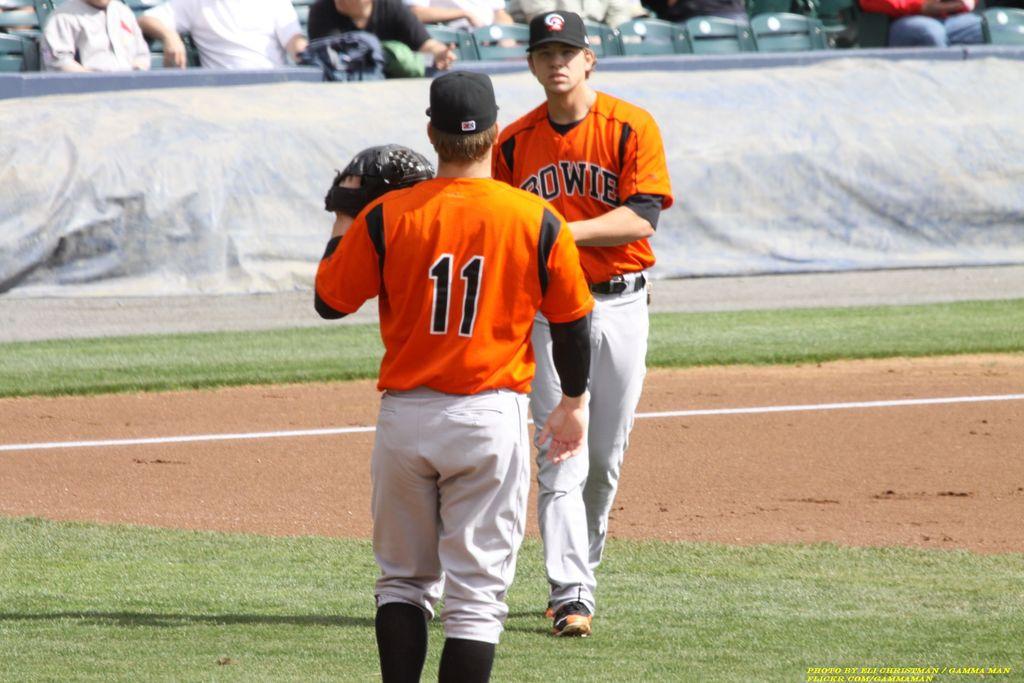What number is the player with the glove?
Ensure brevity in your answer.  11. What is mentioned on the front of the jersey?
Your response must be concise. Bowie. 